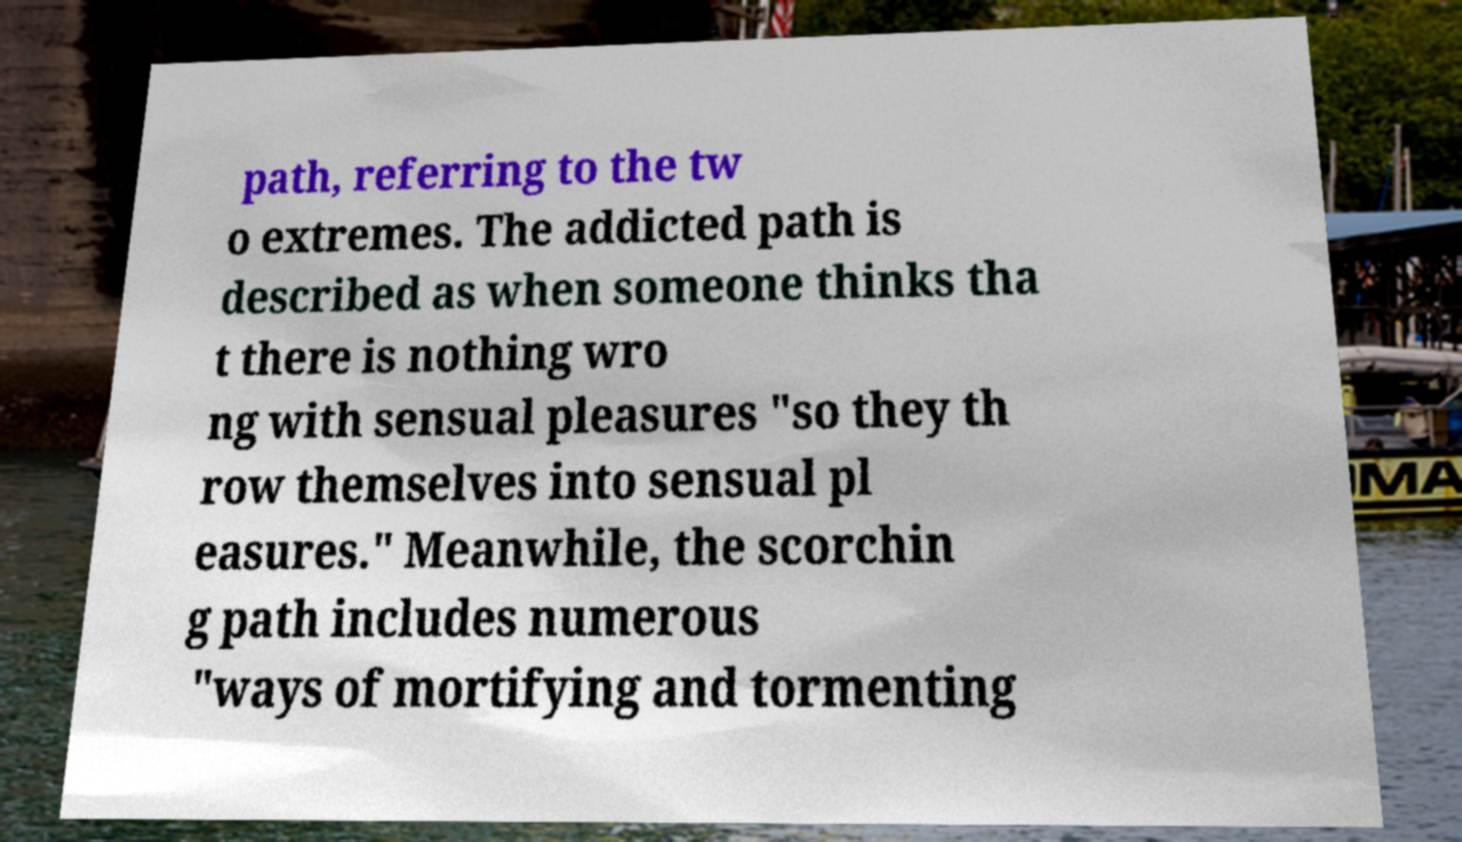Can you read and provide the text displayed in the image?This photo seems to have some interesting text. Can you extract and type it out for me? path, referring to the tw o extremes. The addicted path is described as when someone thinks tha t there is nothing wro ng with sensual pleasures "so they th row themselves into sensual pl easures." Meanwhile, the scorchin g path includes numerous "ways of mortifying and tormenting 